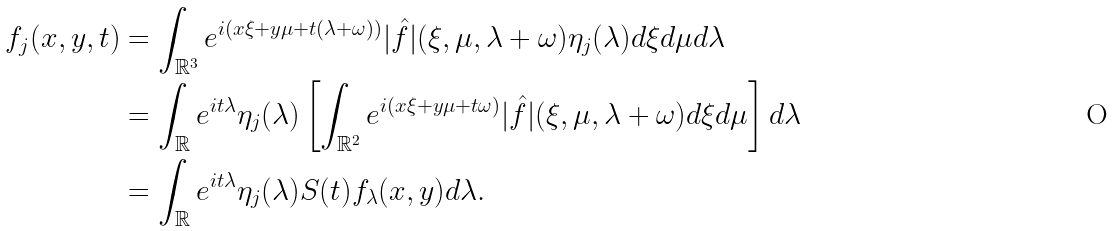<formula> <loc_0><loc_0><loc_500><loc_500>f _ { j } ( x , y , t ) & = \int _ { \mathbb { R } ^ { 3 } } e ^ { i ( x \xi + y \mu + t ( \lambda + \omega ) ) } | \hat { f } | ( \xi , \mu , \lambda + \omega ) \eta _ { j } ( \lambda ) d \xi d \mu d \lambda \\ & = \int _ { \mathbb { R } } e ^ { i t \lambda } \eta _ { j } ( \lambda ) \left [ \int _ { \mathbb { R } ^ { 2 } } e ^ { i ( x \xi + y \mu + t \omega ) } | \hat { f } | ( \xi , \mu , \lambda + \omega ) d \xi d \mu \right ] d \lambda \\ & = \int _ { \mathbb { R } } e ^ { i t \lambda } \eta _ { j } ( \lambda ) S ( t ) f _ { \lambda } ( x , y ) d \lambda .</formula> 